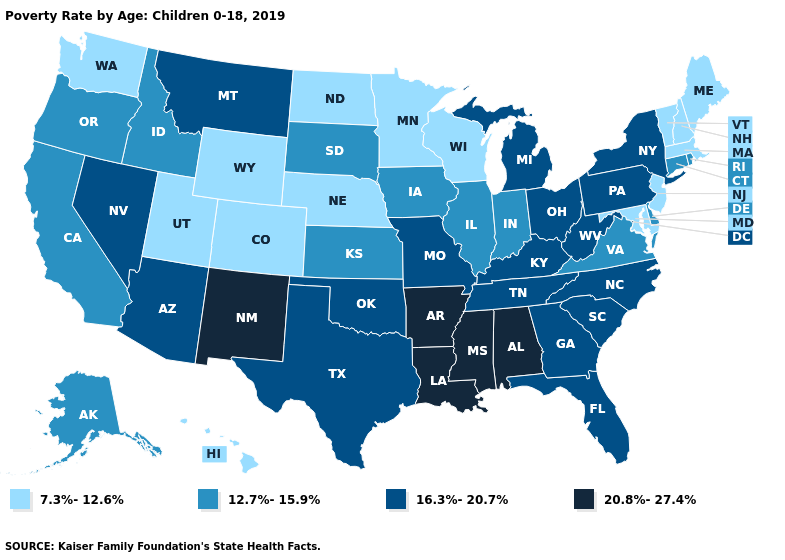What is the value of Wyoming?
Answer briefly. 7.3%-12.6%. What is the value of Florida?
Answer briefly. 16.3%-20.7%. Which states have the lowest value in the South?
Write a very short answer. Maryland. Does Maine have the highest value in the USA?
Short answer required. No. Does the first symbol in the legend represent the smallest category?
Concise answer only. Yes. Does Florida have a lower value than New Mexico?
Concise answer only. Yes. What is the value of Georgia?
Quick response, please. 16.3%-20.7%. Which states have the highest value in the USA?
Short answer required. Alabama, Arkansas, Louisiana, Mississippi, New Mexico. What is the value of Maryland?
Be succinct. 7.3%-12.6%. What is the value of Michigan?
Answer briefly. 16.3%-20.7%. Does the map have missing data?
Write a very short answer. No. Does South Dakota have the lowest value in the USA?
Give a very brief answer. No. Does Idaho have the highest value in the West?
Short answer required. No. Among the states that border Montana , which have the highest value?
Be succinct. Idaho, South Dakota. 